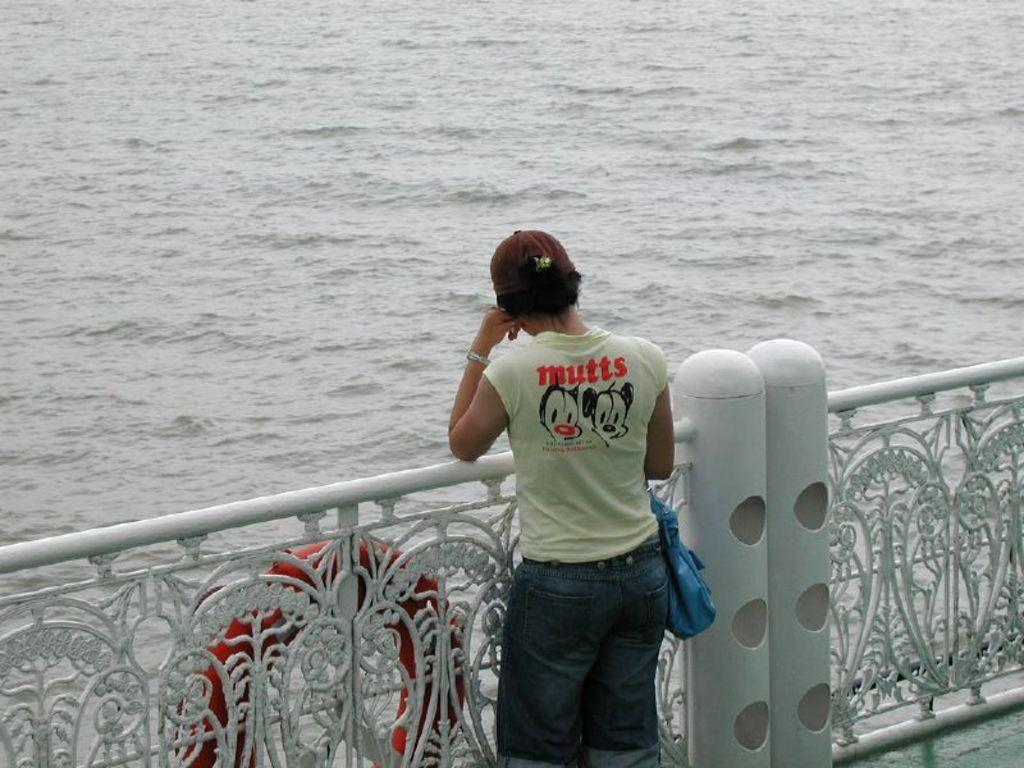What is the main subject of the image? The main subject of the image is a woman. What is the woman doing in the image? The woman is standing and looking at a particular side. What is the woman wearing in the image? The woman is wearing a t-shirt and trousers. What accessory is the woman carrying in the image? The woman is carrying a handbag. What can be seen on the left side of the image? There is a tube-like structure on the left side of the image. What is inside the tube-like structure? The tube-like structure contains water. What type of debt is the woman discussing with her friend in the image? There is no indication in the image that the woman is discussing debt or any financial matters with a friend. 